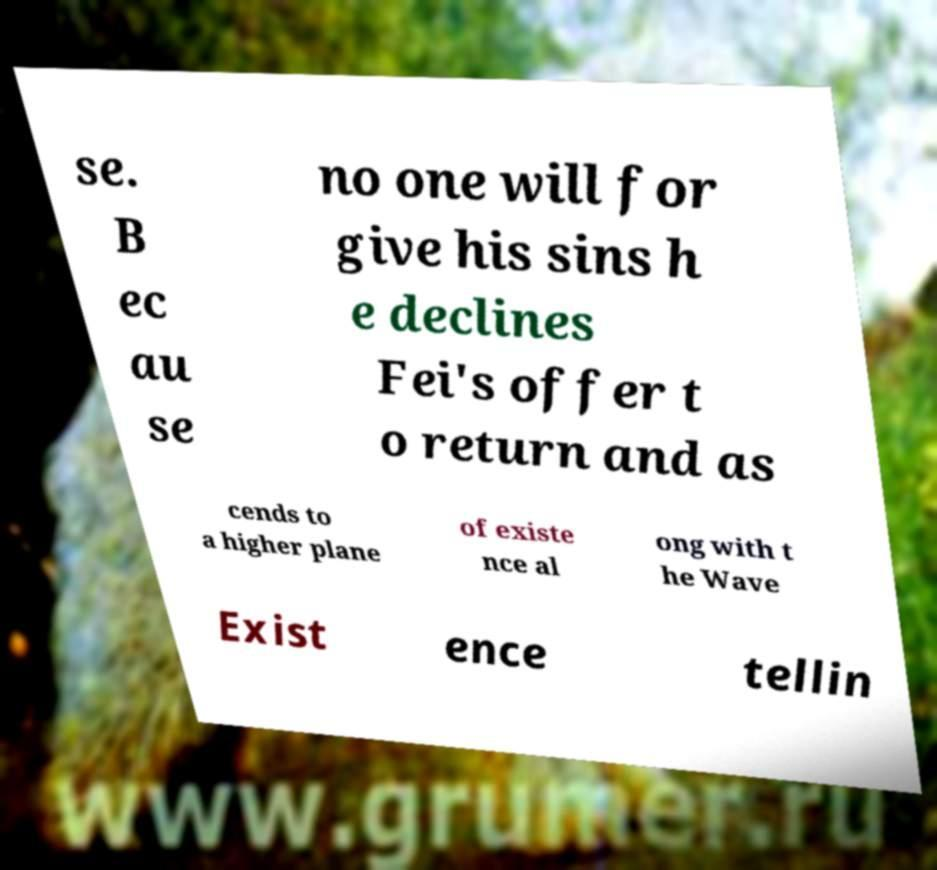What messages or text are displayed in this image? I need them in a readable, typed format. se. B ec au se no one will for give his sins h e declines Fei's offer t o return and as cends to a higher plane of existe nce al ong with t he Wave Exist ence tellin 